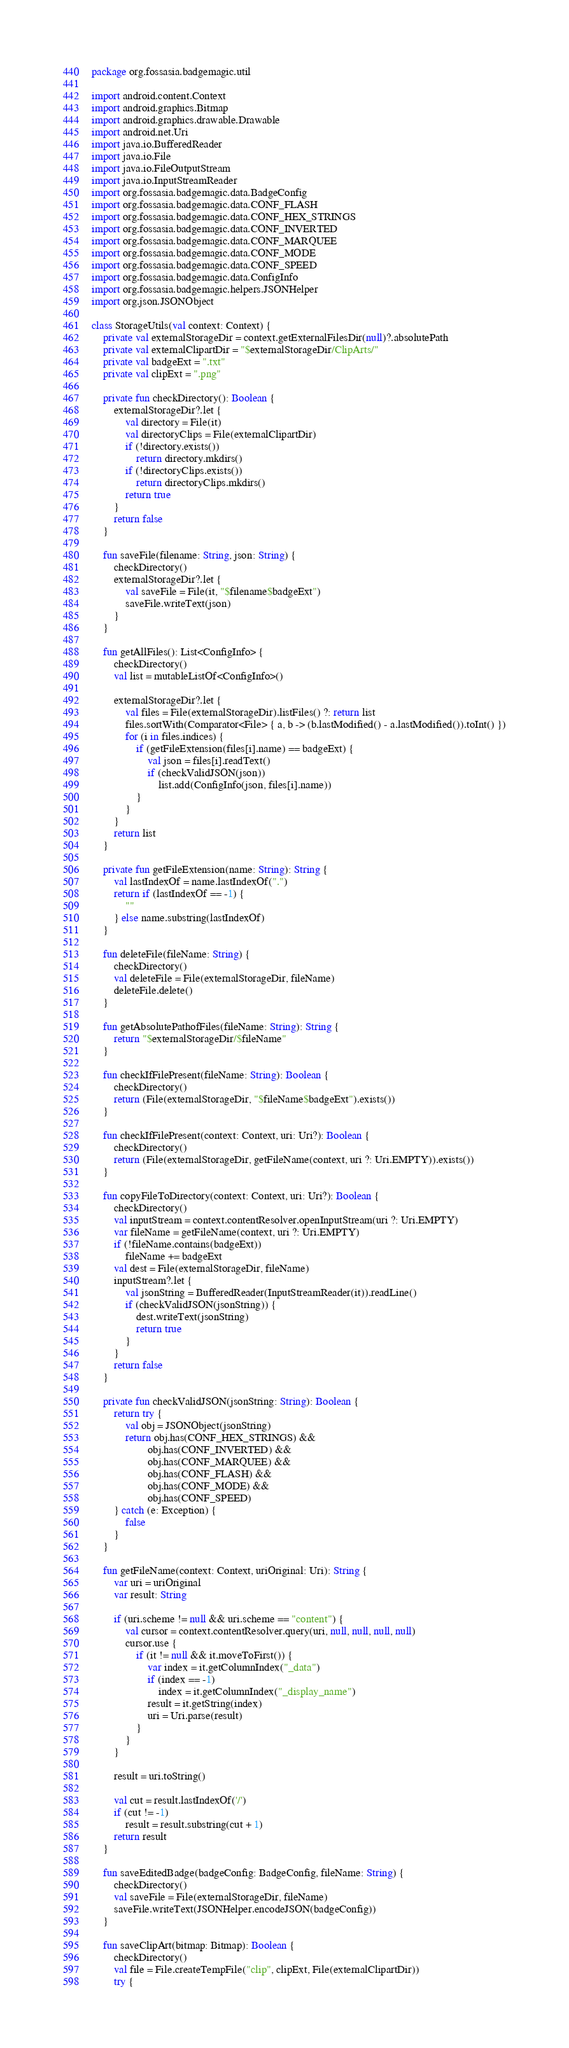<code> <loc_0><loc_0><loc_500><loc_500><_Kotlin_>package org.fossasia.badgemagic.util

import android.content.Context
import android.graphics.Bitmap
import android.graphics.drawable.Drawable
import android.net.Uri
import java.io.BufferedReader
import java.io.File
import java.io.FileOutputStream
import java.io.InputStreamReader
import org.fossasia.badgemagic.data.BadgeConfig
import org.fossasia.badgemagic.data.CONF_FLASH
import org.fossasia.badgemagic.data.CONF_HEX_STRINGS
import org.fossasia.badgemagic.data.CONF_INVERTED
import org.fossasia.badgemagic.data.CONF_MARQUEE
import org.fossasia.badgemagic.data.CONF_MODE
import org.fossasia.badgemagic.data.CONF_SPEED
import org.fossasia.badgemagic.data.ConfigInfo
import org.fossasia.badgemagic.helpers.JSONHelper
import org.json.JSONObject

class StorageUtils(val context: Context) {
    private val externalStorageDir = context.getExternalFilesDir(null)?.absolutePath
    private val externalClipartDir = "$externalStorageDir/ClipArts/"
    private val badgeExt = ".txt"
    private val clipExt = ".png"

    private fun checkDirectory(): Boolean {
        externalStorageDir?.let {
            val directory = File(it)
            val directoryClips = File(externalClipartDir)
            if (!directory.exists())
                return directory.mkdirs()
            if (!directoryClips.exists())
                return directoryClips.mkdirs()
            return true
        }
        return false
    }

    fun saveFile(filename: String, json: String) {
        checkDirectory()
        externalStorageDir?.let {
            val saveFile = File(it, "$filename$badgeExt")
            saveFile.writeText(json)
        }
    }

    fun getAllFiles(): List<ConfigInfo> {
        checkDirectory()
        val list = mutableListOf<ConfigInfo>()

        externalStorageDir?.let {
            val files = File(externalStorageDir).listFiles() ?: return list
            files.sortWith(Comparator<File> { a, b -> (b.lastModified() - a.lastModified()).toInt() })
            for (i in files.indices) {
                if (getFileExtension(files[i].name) == badgeExt) {
                    val json = files[i].readText()
                    if (checkValidJSON(json))
                        list.add(ConfigInfo(json, files[i].name))
                }
            }
        }
        return list
    }

    private fun getFileExtension(name: String): String {
        val lastIndexOf = name.lastIndexOf(".")
        return if (lastIndexOf == -1) {
            ""
        } else name.substring(lastIndexOf)
    }

    fun deleteFile(fileName: String) {
        checkDirectory()
        val deleteFile = File(externalStorageDir, fileName)
        deleteFile.delete()
    }

    fun getAbsolutePathofFiles(fileName: String): String {
        return "$externalStorageDir/$fileName"
    }

    fun checkIfFilePresent(fileName: String): Boolean {
        checkDirectory()
        return (File(externalStorageDir, "$fileName$badgeExt").exists())
    }

    fun checkIfFilePresent(context: Context, uri: Uri?): Boolean {
        checkDirectory()
        return (File(externalStorageDir, getFileName(context, uri ?: Uri.EMPTY)).exists())
    }

    fun copyFileToDirectory(context: Context, uri: Uri?): Boolean {
        checkDirectory()
        val inputStream = context.contentResolver.openInputStream(uri ?: Uri.EMPTY)
        var fileName = getFileName(context, uri ?: Uri.EMPTY)
        if (!fileName.contains(badgeExt))
            fileName += badgeExt
        val dest = File(externalStorageDir, fileName)
        inputStream?.let {
            val jsonString = BufferedReader(InputStreamReader(it)).readLine()
            if (checkValidJSON(jsonString)) {
                dest.writeText(jsonString)
                return true
            }
        }
        return false
    }

    private fun checkValidJSON(jsonString: String): Boolean {
        return try {
            val obj = JSONObject(jsonString)
            return obj.has(CONF_HEX_STRINGS) &&
                    obj.has(CONF_INVERTED) &&
                    obj.has(CONF_MARQUEE) &&
                    obj.has(CONF_FLASH) &&
                    obj.has(CONF_MODE) &&
                    obj.has(CONF_SPEED)
        } catch (e: Exception) {
            false
        }
    }

    fun getFileName(context: Context, uriOriginal: Uri): String {
        var uri = uriOriginal
        var result: String

        if (uri.scheme != null && uri.scheme == "content") {
            val cursor = context.contentResolver.query(uri, null, null, null, null)
            cursor.use {
                if (it != null && it.moveToFirst()) {
                    var index = it.getColumnIndex("_data")
                    if (index == -1)
                        index = it.getColumnIndex("_display_name")
                    result = it.getString(index)
                    uri = Uri.parse(result)
                }
            }
        }

        result = uri.toString()

        val cut = result.lastIndexOf('/')
        if (cut != -1)
            result = result.substring(cut + 1)
        return result
    }

    fun saveEditedBadge(badgeConfig: BadgeConfig, fileName: String) {
        checkDirectory()
        val saveFile = File(externalStorageDir, fileName)
        saveFile.writeText(JSONHelper.encodeJSON(badgeConfig))
    }

    fun saveClipArt(bitmap: Bitmap): Boolean {
        checkDirectory()
        val file = File.createTempFile("clip", clipExt, File(externalClipartDir))
        try {</code> 